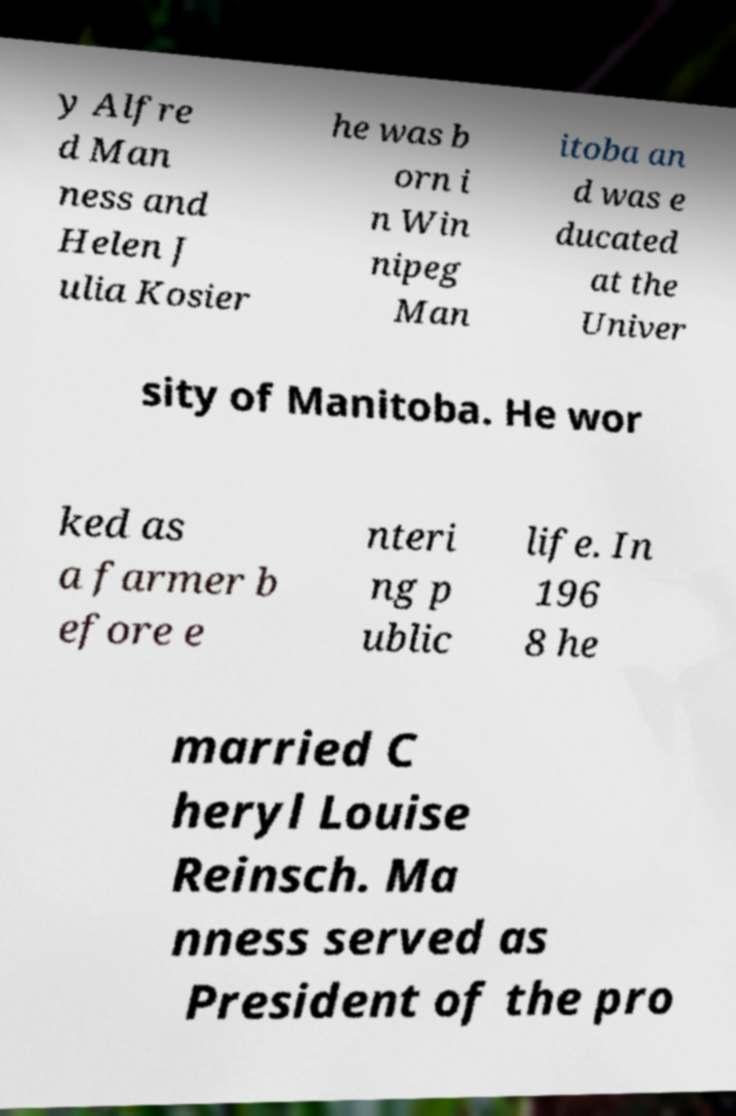Please read and relay the text visible in this image. What does it say? y Alfre d Man ness and Helen J ulia Kosier he was b orn i n Win nipeg Man itoba an d was e ducated at the Univer sity of Manitoba. He wor ked as a farmer b efore e nteri ng p ublic life. In 196 8 he married C heryl Louise Reinsch. Ma nness served as President of the pro 